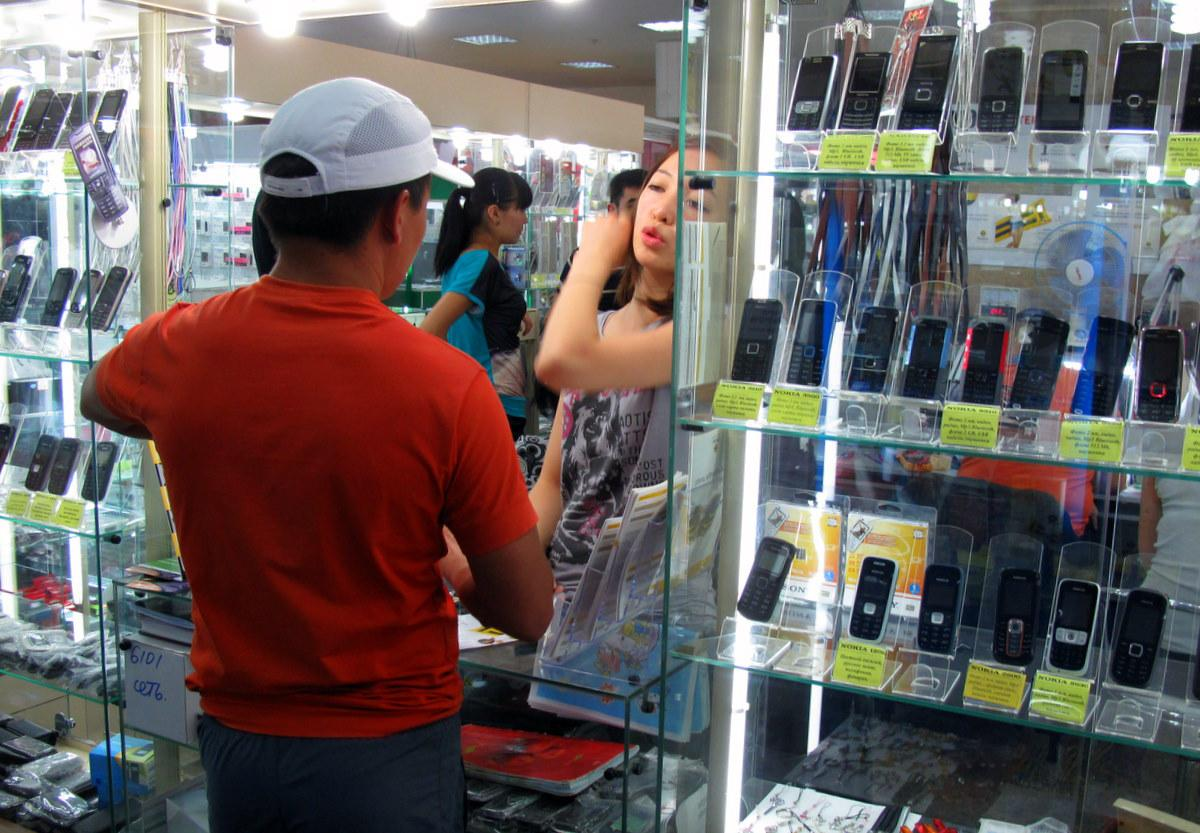Question: why are the phones displayed?
Choices:
A. They are new brands.
B. They are for show.
C. They are shiny.
D. They are for sale.
Answer with the letter. Answer: D Question: what color hat is the man wearing?
Choices:
A. White.
B. Red.
C. Orange.
D. Purple.
Answer with the letter. Answer: A Question: where is this photo taken?
Choices:
A. At the beach house.
B. At my work.
C. A store.
D. At the new house.
Answer with the letter. Answer: C Question: what are the phones sitting in?
Choices:
A. An old shoebox.
B. The desk drawer.
C. A display case.
D. The big garbage bag.
Answer with the letter. Answer: C Question: what color shirt is the man wearing?
Choices:
A. White.
B. Black.
C. Blue.
D. Red.
Answer with the letter. Answer: D Question: what lines the shelves?
Choices:
A. Cell phones.
B. Books.
C. Mon-ey, Mon-ey,  money, money, money.
D. Food. And more food.
Answer with the letter. Answer: A Question: where is the young woman standing?
Choices:
A. Behind the counter.
B. At the book store.
C. At a food store.
D. At a hospital.
Answer with the letter. Answer: A Question: what is being displayed?
Choices:
A. Radios.
B. Cell phones.
C. Elctronics.
D. Home Phones.
Answer with the letter. Answer: B Question: who is holding a sling bag?
Choices:
A. A man.
B. The woman in the background.
C. Me.
D. You.
Answer with the letter. Answer: B Question: what is the woman pointing at?
Choices:
A. A monster.
B. Something behind her.
C. Finnick Odair.
D. Newt from The Maze Runner. (NOT! Newt's dead.).
Answer with the letter. Answer: B Question: what color lipstick is the woman wearing?
Choices:
A. Pink.
B. Black.
C. Red.
D. Maroon.
Answer with the letter. Answer: C Question: what color shirt is the woman in the background wearing?
Choices:
A. White.
B. Black.
C. Turquoise.
D. Red.
Answer with the letter. Answer: C Question: what color card is under most of the phones?
Choices:
A. Yellow.
B. Red.
C. Black.
D. White.
Answer with the letter. Answer: A Question: where are the pamphlets?
Choices:
A. In the man's hands.
B. On the counter.
C. Scattered on the sidewalk.
D. On the table.
Answer with the letter. Answer: B Question: who is wearing a white cap?
Choices:
A. The tennis player on the right.
B. The bus driver.
C. The woman at the table.
D. A man.
Answer with the letter. Answer: D Question: how do the lights look?
Choices:
A. They are flickering.
B. They are too low.
C. Bright.
D. They are just right.
Answer with the letter. Answer: C Question: what shape are the recessed ceiling lights?
Choices:
A. Rectangular.
B. Horizontal Lines.
C. Circular.
D. Square.
Answer with the letter. Answer: D Question: how is the man positioned?
Choices:
A. He is laying down.
B. Curled up in a ball.
C. He is standing.
D. His back is turned.
Answer with the letter. Answer: D 